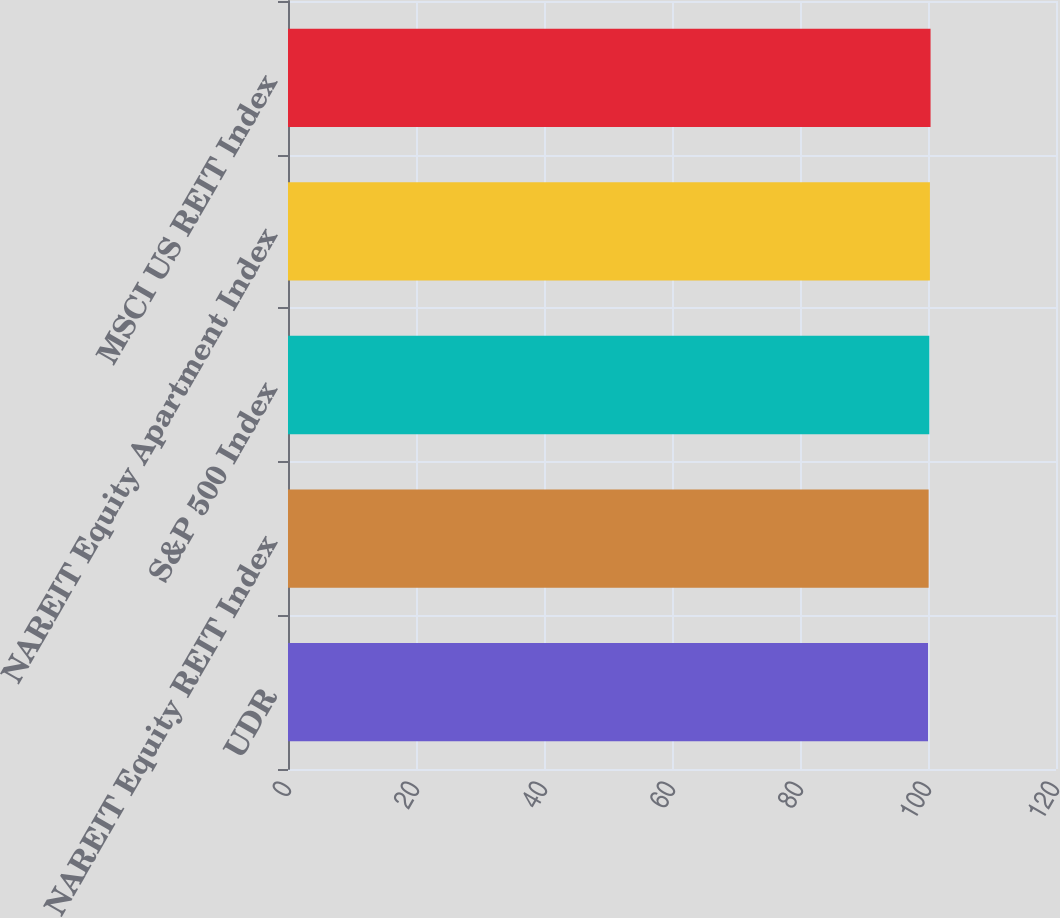<chart> <loc_0><loc_0><loc_500><loc_500><bar_chart><fcel>UDR<fcel>NAREIT Equity REIT Index<fcel>S&P 500 Index<fcel>NAREIT Equity Apartment Index<fcel>MSCI US REIT Index<nl><fcel>100<fcel>100.1<fcel>100.2<fcel>100.3<fcel>100.4<nl></chart> 